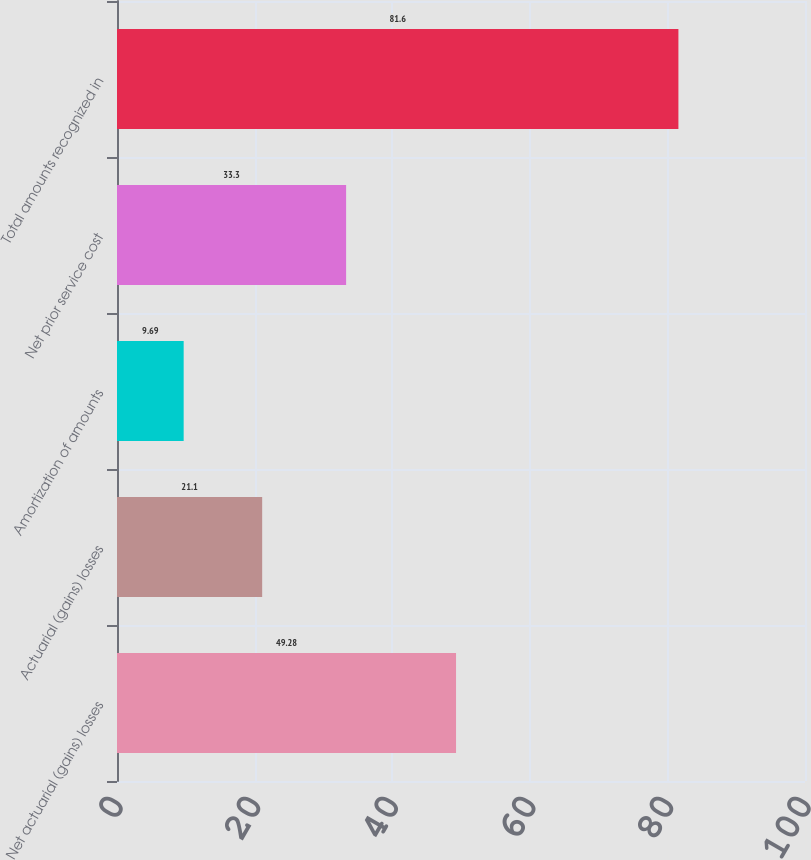<chart> <loc_0><loc_0><loc_500><loc_500><bar_chart><fcel>Net actuarial (gains) losses<fcel>Actuarial (gains) losses<fcel>Amortization of amounts<fcel>Net prior service cost<fcel>Total amounts recognized in<nl><fcel>49.28<fcel>21.1<fcel>9.69<fcel>33.3<fcel>81.6<nl></chart> 